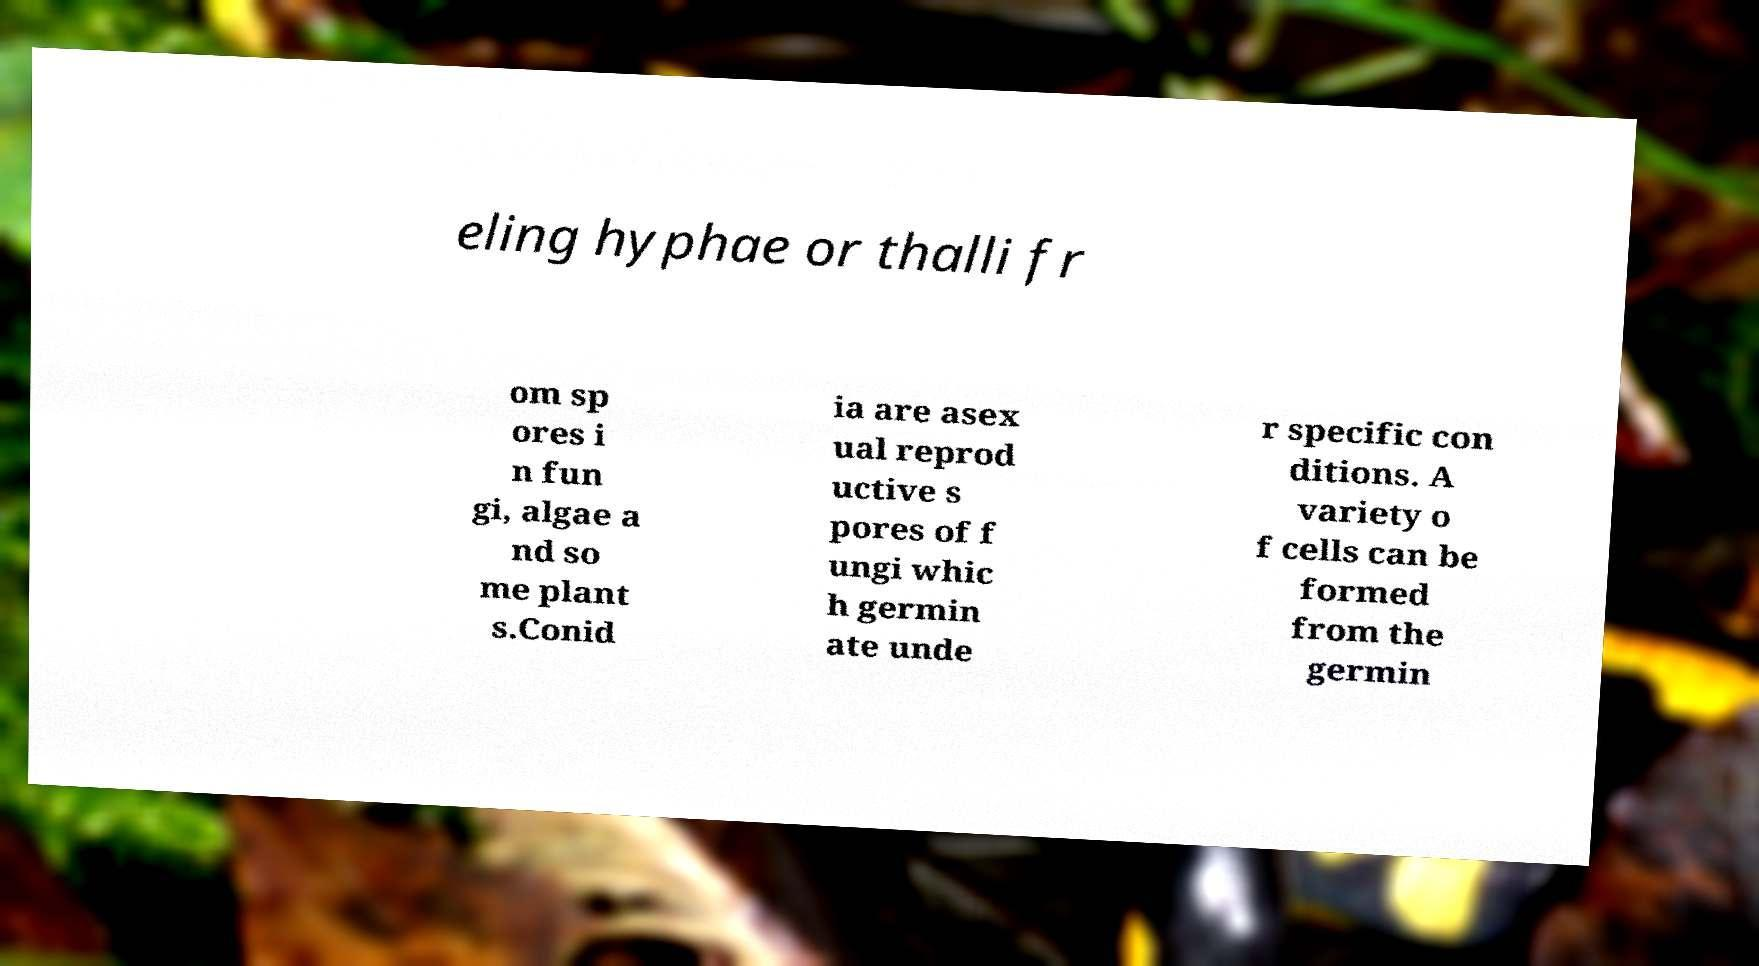There's text embedded in this image that I need extracted. Can you transcribe it verbatim? eling hyphae or thalli fr om sp ores i n fun gi, algae a nd so me plant s.Conid ia are asex ual reprod uctive s pores of f ungi whic h germin ate unde r specific con ditions. A variety o f cells can be formed from the germin 